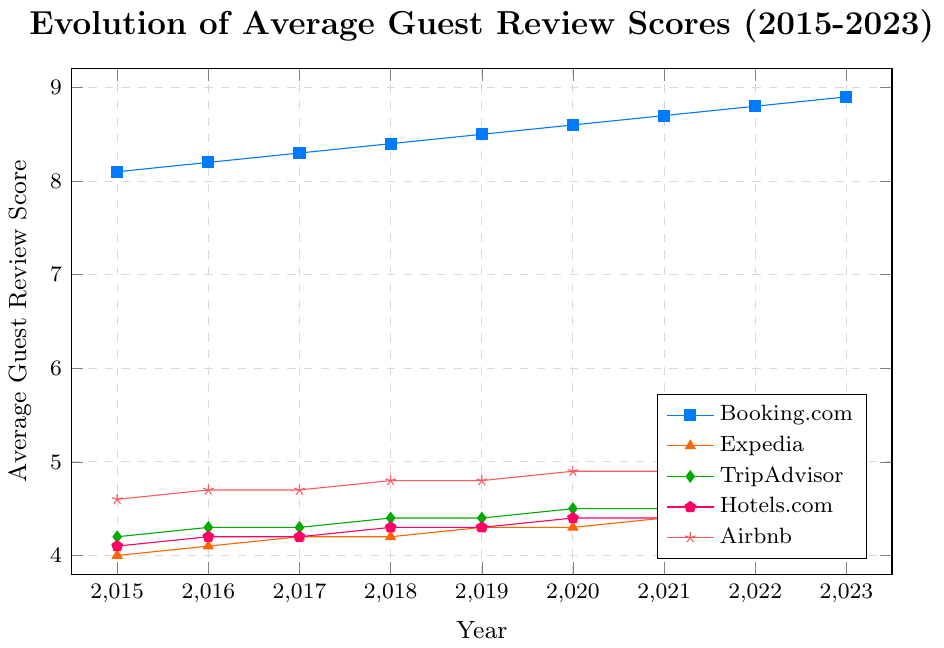Which platform had the highest average guest review score in 2023? In 2023, the guests' scores for Booking.com were 8.9, Expedia was 4.5, TripAdvisor was 4.6, Hotels.com was 4.5, and Airbnb was 5.0. Airbnb had the highest score.
Answer: Airbnb Which platform's average guest review score increased the most from 2015 to 2023? For each platform, subtract the score in 2015 from the score in 2023. Booking.com increased by 0.8 (8.9-8.1), Expedia by 0.5 (4.5-4.0), TripAdvisor by 0.4 (4.6-4.2), Hotels.com by 0.4 (4.5-4.1), and Airbnb by 0.4 (5.0-4.6). Booking.com had the highest increase.
Answer: Booking.com In which year did Expedia's average guest review score reach 4.4? Look for the year where the score for Expedia crosses 4.4. It happened in 2021.
Answer: 2021 Which platform had the lowest average guest review score in 2020? In 2020, the scores were Booking.com at 8.6, Expedia at 4.3, TripAdvisor at 4.5, Hotels.com at 4.4, and Airbnb at 4.9. Expedia had the lowest score.
Answer: Expedia By how much did the average guest review score for TripAdvisor change between 2015 and 2023? Subtract the score in 2015 from the score in 2023 for TripAdvisor: 4.6 - 4.2 = 0.4.
Answer: 0.4 Which two platforms had the same average guest review score in 2018, and what was the score? In 2018, the scores were Booking.com 8.4, Expedia 4.2, TripAdvisor 4.4, Hotels.com 4.3, and Airbnb 4.8. Compare the values to see that Expedia and TripAdvisor both had a score of 4.2.
Answer: Expedia and TripAdvisor, 4.2 What is the difference between the average guest review scores of Booking.com and Airbnb in 2023? For 2023, subtract the score of Booking.com from Airbnb: 5.0 - 8.9 = -3.9.
Answer: -3.9 Which platform showed consistent growth each year from 2015 to 2023? Check the data for each platform to see if the score increased every year. Booking.com shows consistent growth from 8.1 to 8.9, increasing every year.
Answer: Booking.com Were there any years where the average guest review scores for all platforms remained the same or decreased compared to the previous year? Checking the data, all platforms show either an increase or remain the same in their scores each year from 2015 to 2023, with no decreases.
Answer: No 